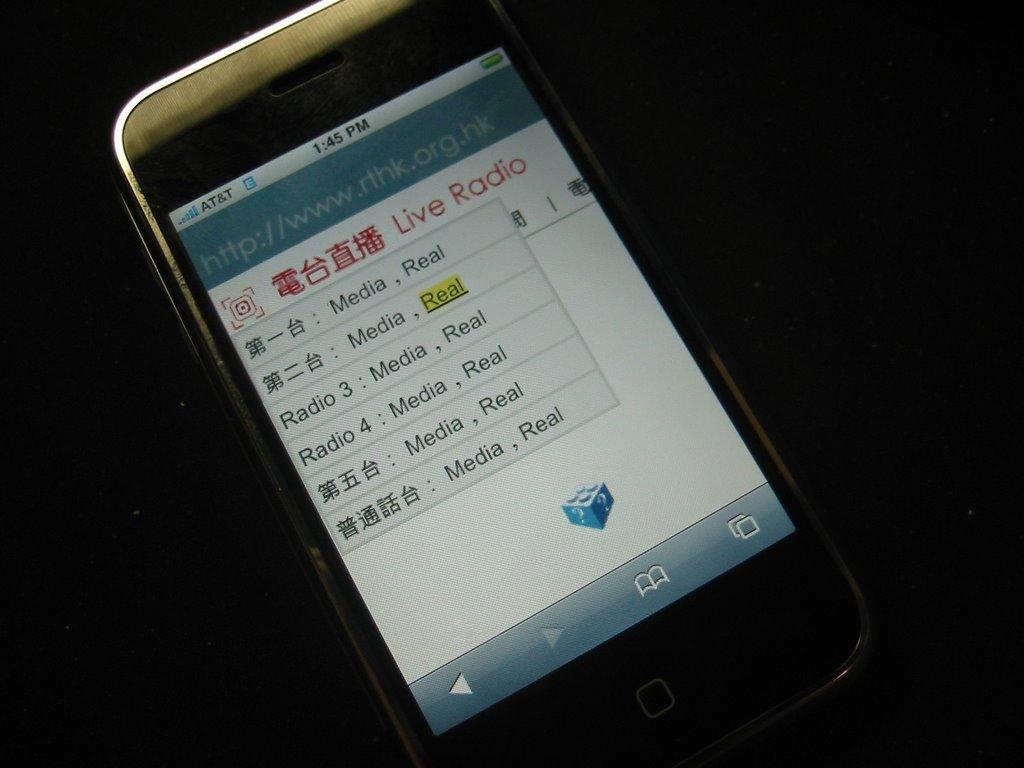<image>
Provide a brief description of the given image. A phone shows several entries in Live Radio. 